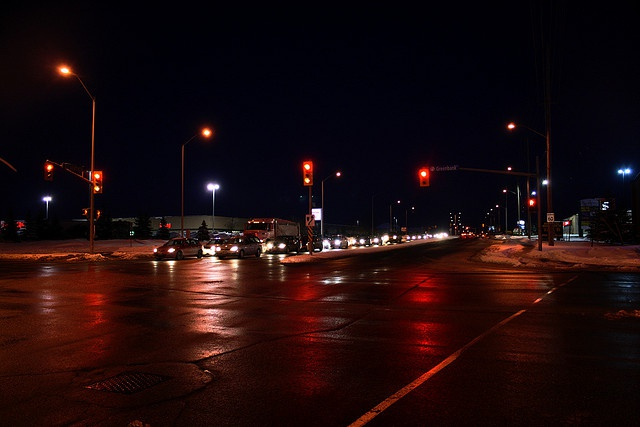Describe the objects in this image and their specific colors. I can see truck in black, maroon, brown, and white tones, car in black, maroon, and white tones, car in black, maroon, and white tones, car in black, gray, lavender, and maroon tones, and car in black, maroon, white, and brown tones in this image. 